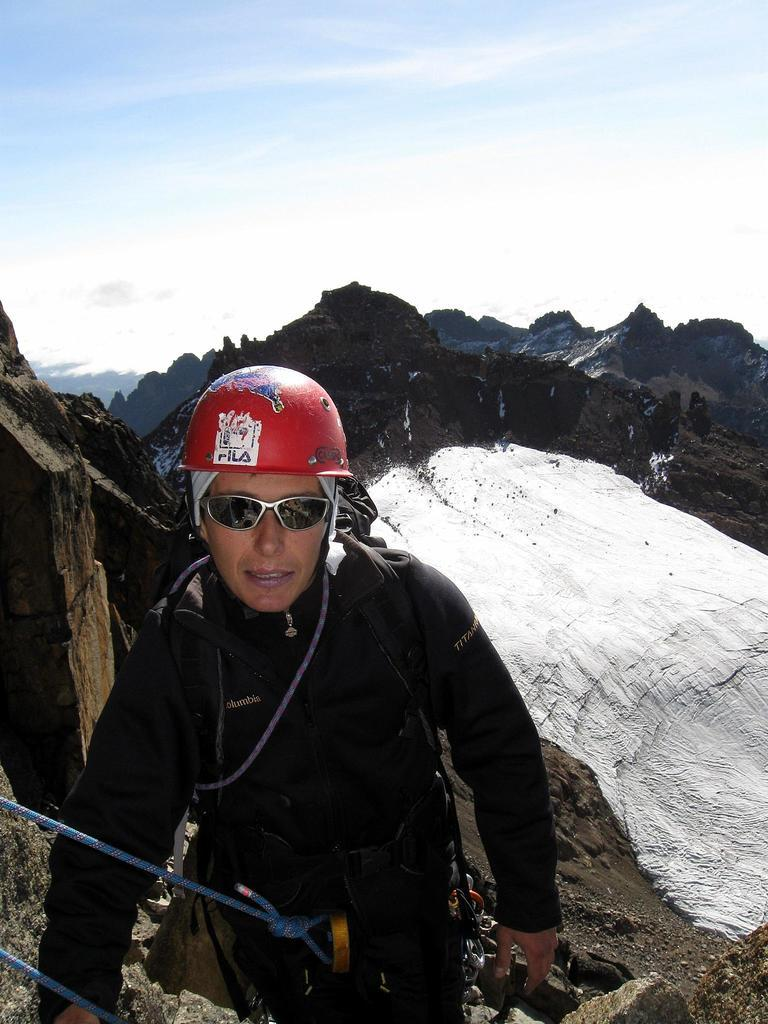Who is the main subject in the foreground of the image? There is a man in the foreground of the image. What is the man wearing on his head? The man is wearing a helmet. What type of eyewear is the man wearing? The man is wearing glasses. What can be seen in the background of the image? There is a sky visible in the background of the image. What type of landscape feature is present in the middle of the image? There are mountains in the middle of the image. What type of lock can be seen on the corn in the image? There is no corn or lock present in the image. What type of house is visible in the image? There is no house visible in the image; it features a man wearing a helmet and glasses, mountains, and a sky. 